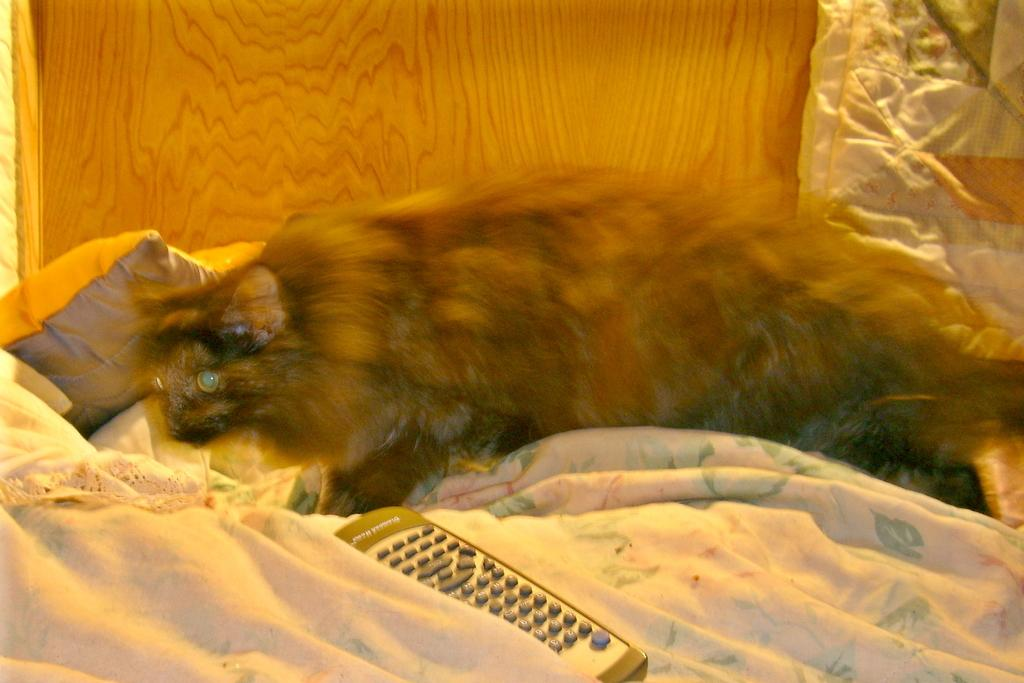What type of animal is on the bed in the image? There is an animal on the bed in the image, but the specific type is not mentioned. What can be seen on the bed besides the animal? There is a pillow visible on the bed in the image. What object is present that is typically used for controlling electronic devices? There is a remote in the image. What can be seen in the background of the image? There is a wall visible in the background of the image. What type of pin is being used for the discussion in the image? There is no discussion or pin present in the image. 